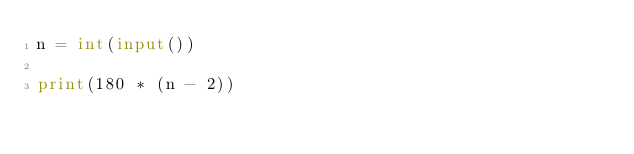<code> <loc_0><loc_0><loc_500><loc_500><_Python_>n = int(input())

print(180 * (n - 2))
</code> 